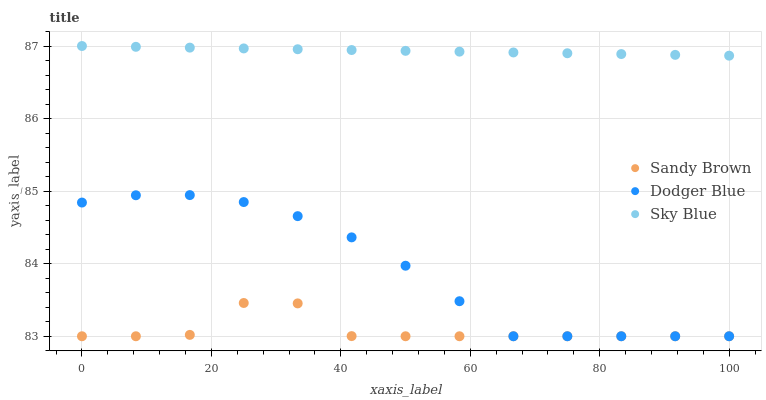Does Sandy Brown have the minimum area under the curve?
Answer yes or no. Yes. Does Sky Blue have the maximum area under the curve?
Answer yes or no. Yes. Does Sky Blue have the minimum area under the curve?
Answer yes or no. No. Does Sandy Brown have the maximum area under the curve?
Answer yes or no. No. Is Sky Blue the smoothest?
Answer yes or no. Yes. Is Sandy Brown the roughest?
Answer yes or no. Yes. Is Sandy Brown the smoothest?
Answer yes or no. No. Is Sky Blue the roughest?
Answer yes or no. No. Does Dodger Blue have the lowest value?
Answer yes or no. Yes. Does Sky Blue have the lowest value?
Answer yes or no. No. Does Sky Blue have the highest value?
Answer yes or no. Yes. Does Sandy Brown have the highest value?
Answer yes or no. No. Is Dodger Blue less than Sky Blue?
Answer yes or no. Yes. Is Sky Blue greater than Dodger Blue?
Answer yes or no. Yes. Does Sandy Brown intersect Dodger Blue?
Answer yes or no. Yes. Is Sandy Brown less than Dodger Blue?
Answer yes or no. No. Is Sandy Brown greater than Dodger Blue?
Answer yes or no. No. Does Dodger Blue intersect Sky Blue?
Answer yes or no. No. 